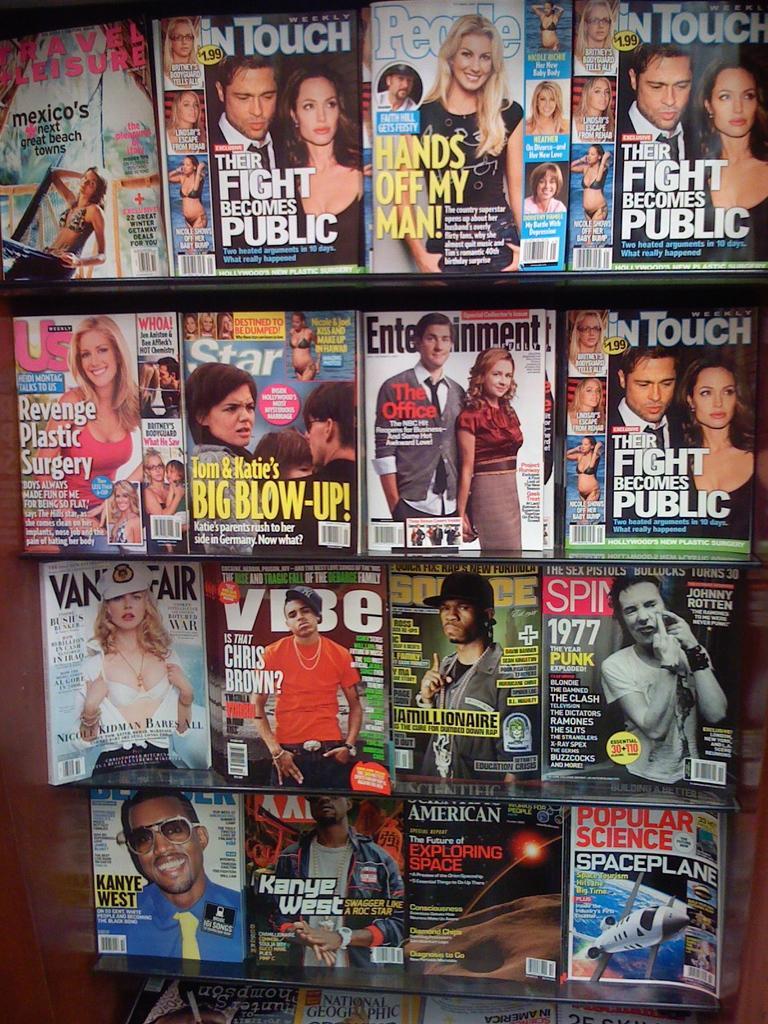Describe this image in one or two sentences. In this image we can see there are racks. And in that racks there are books. In that there are images and text written on it. 